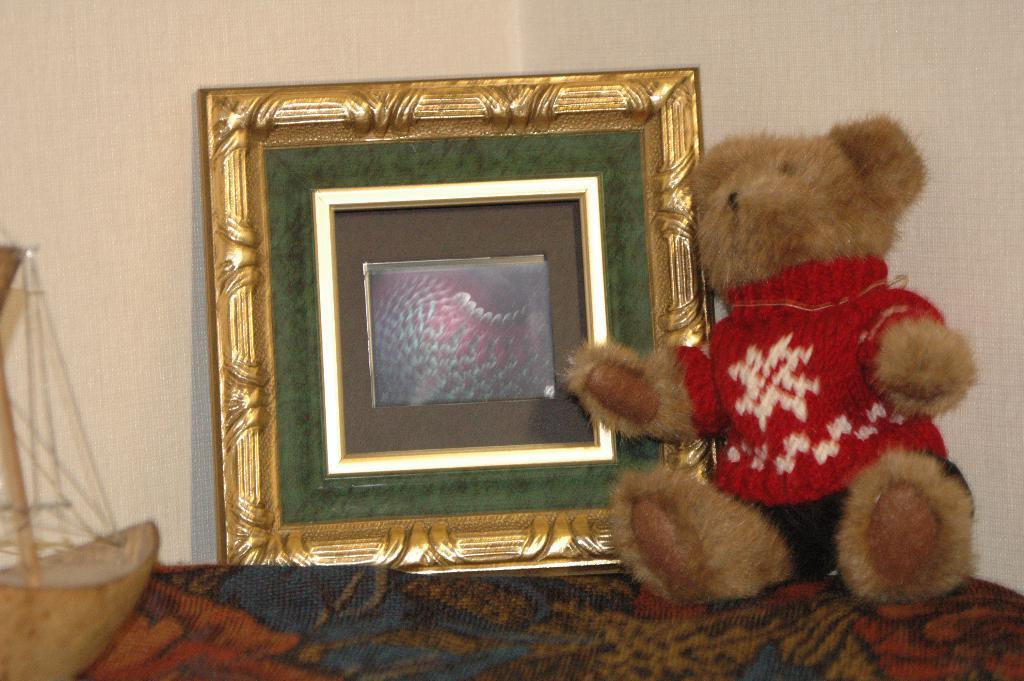What object is located on the left side of the image? There is a toy boat on the left side of the image. What type of object is present in the image that typically holds photos? There is a photo frame in the image. What type of stuffed animal can be seen in the image? There is a teddy bear in the image. What is visible in the background of the image? There is a wall in the background of the image. How many cherries are on the teddy bear's suit in the image? There are no cherries or suits present in the image; it features a toy boat, a photo frame, a teddy bear, and a wall in the background. 